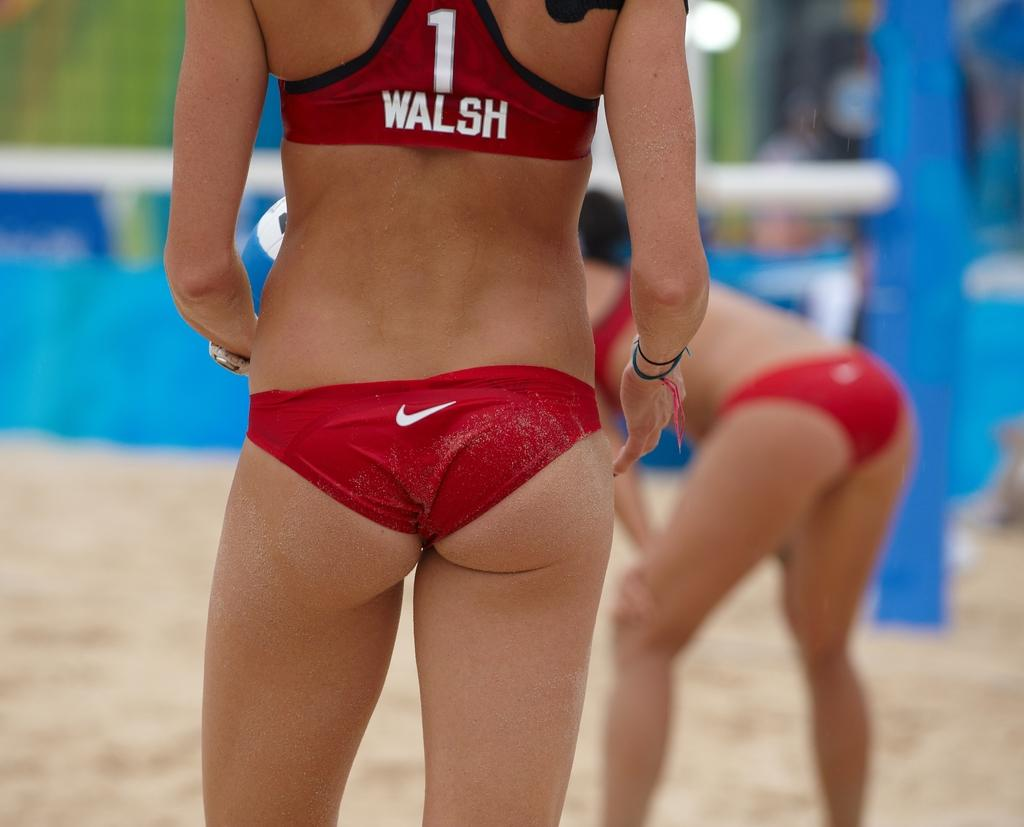<image>
Relay a brief, clear account of the picture shown. Sportswoman Walsh stands on sand wearing red clothing. 